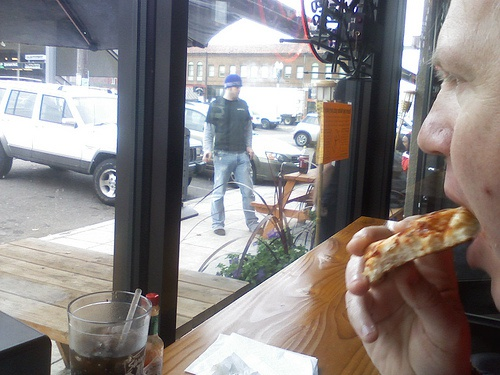Describe the objects in this image and their specific colors. I can see people in gray, darkgray, and maroon tones, dining table in gray, lightgray, brown, and darkgray tones, dining table in gray, darkgray, lightgray, and black tones, truck in gray, white, and darkgray tones, and cup in gray, darkgray, and black tones in this image. 